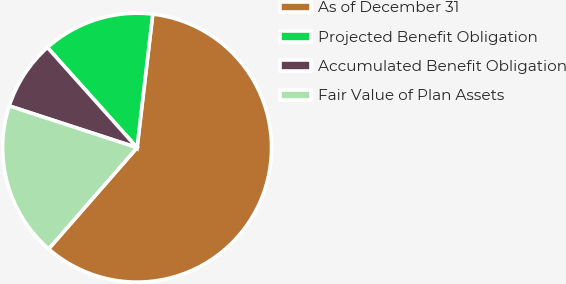Convert chart to OTSL. <chart><loc_0><loc_0><loc_500><loc_500><pie_chart><fcel>As of December 31<fcel>Projected Benefit Obligation<fcel>Accumulated Benefit Obligation<fcel>Fair Value of Plan Assets<nl><fcel>59.57%<fcel>13.48%<fcel>8.36%<fcel>18.6%<nl></chart> 